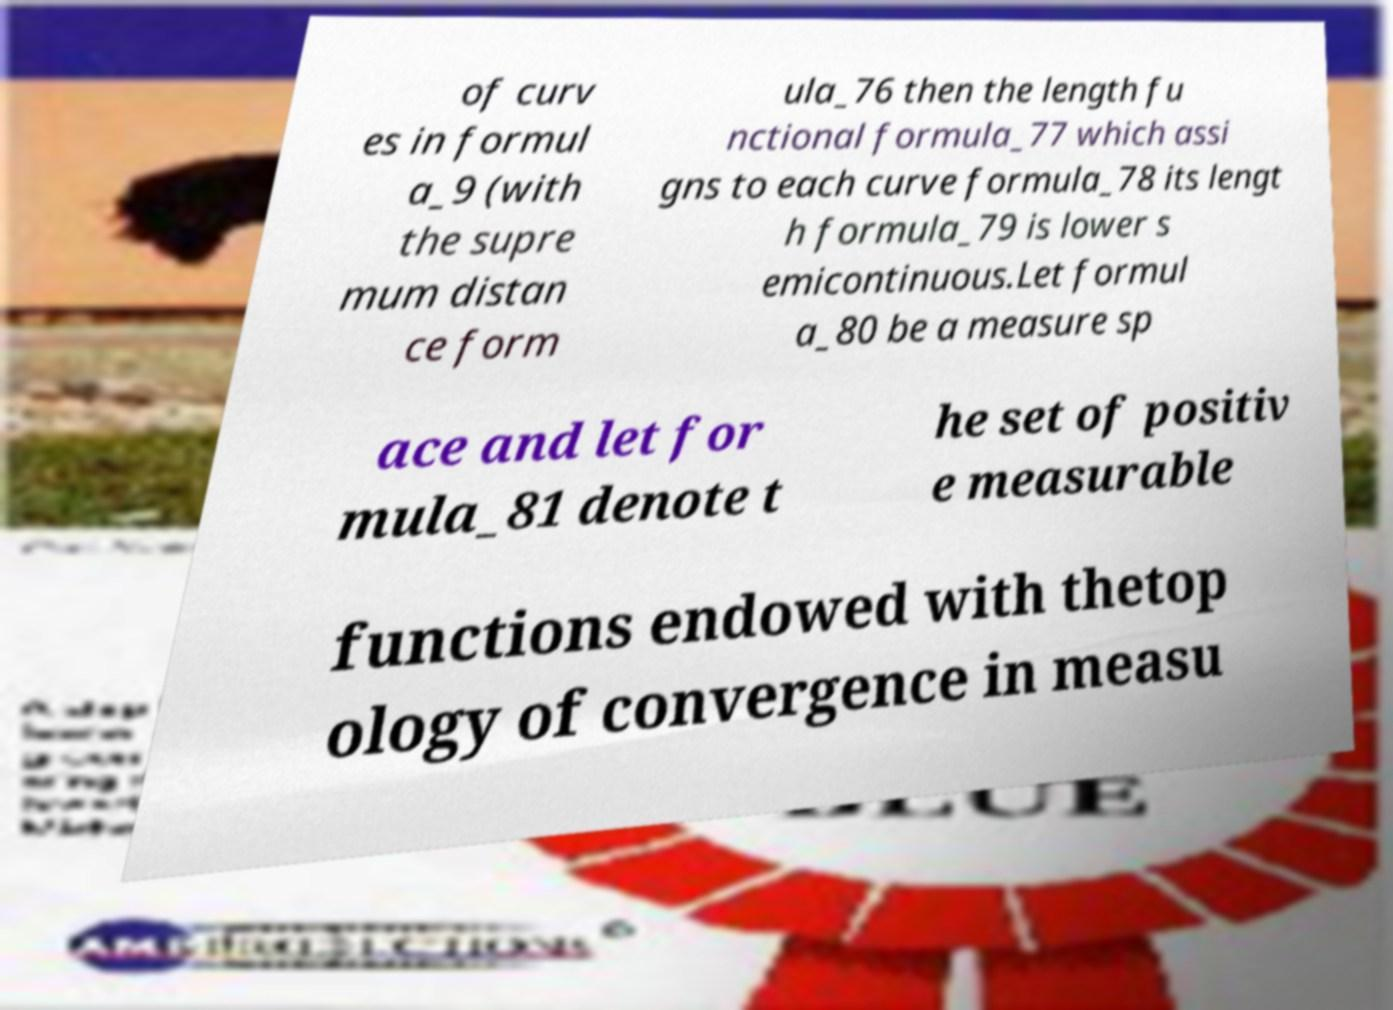Can you accurately transcribe the text from the provided image for me? of curv es in formul a_9 (with the supre mum distan ce form ula_76 then the length fu nctional formula_77 which assi gns to each curve formula_78 its lengt h formula_79 is lower s emicontinuous.Let formul a_80 be a measure sp ace and let for mula_81 denote t he set of positiv e measurable functions endowed with thetop ology of convergence in measu 